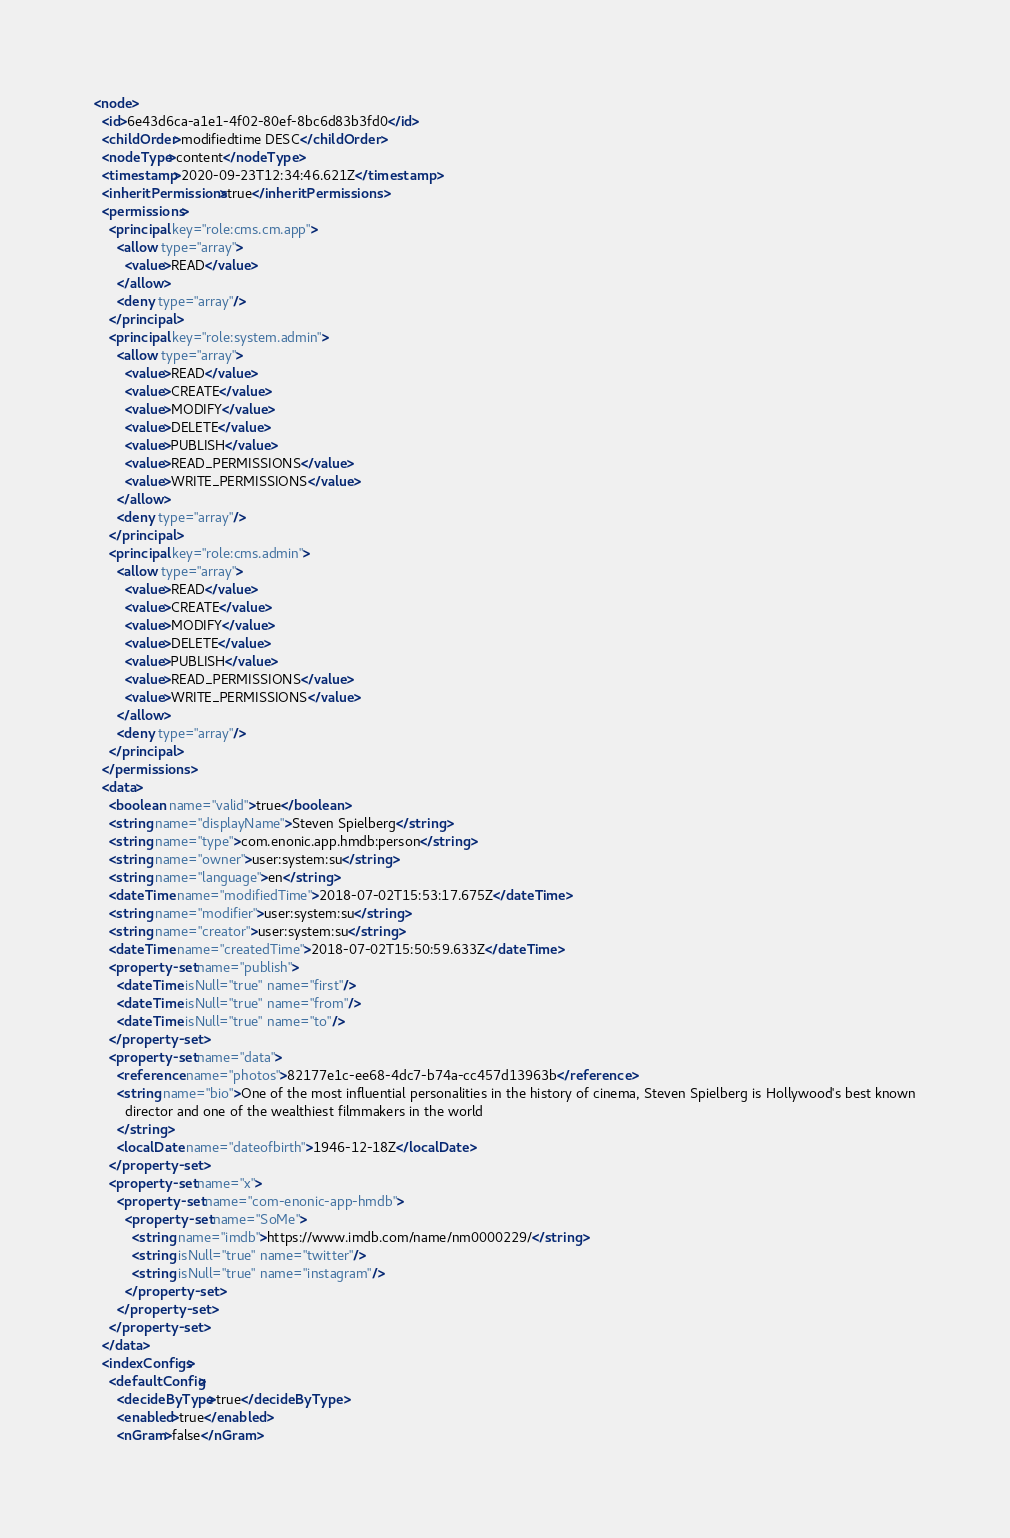Convert code to text. <code><loc_0><loc_0><loc_500><loc_500><_XML_><node>
  <id>6e43d6ca-a1e1-4f02-80ef-8bc6d83b3fd0</id>
  <childOrder>modifiedtime DESC</childOrder>
  <nodeType>content</nodeType>
  <timestamp>2020-09-23T12:34:46.621Z</timestamp>
  <inheritPermissions>true</inheritPermissions>
  <permissions>
    <principal key="role:cms.cm.app">
      <allow type="array">
        <value>READ</value>
      </allow>
      <deny type="array"/>
    </principal>
    <principal key="role:system.admin">
      <allow type="array">
        <value>READ</value>
        <value>CREATE</value>
        <value>MODIFY</value>
        <value>DELETE</value>
        <value>PUBLISH</value>
        <value>READ_PERMISSIONS</value>
        <value>WRITE_PERMISSIONS</value>
      </allow>
      <deny type="array"/>
    </principal>
    <principal key="role:cms.admin">
      <allow type="array">
        <value>READ</value>
        <value>CREATE</value>
        <value>MODIFY</value>
        <value>DELETE</value>
        <value>PUBLISH</value>
        <value>READ_PERMISSIONS</value>
        <value>WRITE_PERMISSIONS</value>
      </allow>
      <deny type="array"/>
    </principal>
  </permissions>
  <data>
    <boolean name="valid">true</boolean>
    <string name="displayName">Steven Spielberg</string>
    <string name="type">com.enonic.app.hmdb:person</string>
    <string name="owner">user:system:su</string>
    <string name="language">en</string>
    <dateTime name="modifiedTime">2018-07-02T15:53:17.675Z</dateTime>
    <string name="modifier">user:system:su</string>
    <string name="creator">user:system:su</string>
    <dateTime name="createdTime">2018-07-02T15:50:59.633Z</dateTime>
    <property-set name="publish">
      <dateTime isNull="true" name="first"/>
      <dateTime isNull="true" name="from"/>
      <dateTime isNull="true" name="to"/>
    </property-set>
    <property-set name="data">
      <reference name="photos">82177e1c-ee68-4dc7-b74a-cc457d13963b</reference>
      <string name="bio">One of the most influential personalities in the history of cinema, Steven Spielberg is Hollywood's best known
        director and one of the wealthiest filmmakers in the world
      </string>
      <localDate name="dateofbirth">1946-12-18Z</localDate>
    </property-set>
    <property-set name="x">
      <property-set name="com-enonic-app-hmdb">
        <property-set name="SoMe">
          <string name="imdb">https://www.imdb.com/name/nm0000229/</string>
          <string isNull="true" name="twitter"/>
          <string isNull="true" name="instagram"/>
        </property-set>
      </property-set>
    </property-set>
  </data>
  <indexConfigs>
    <defaultConfig>
      <decideByType>true</decideByType>
      <enabled>true</enabled>
      <nGram>false</nGram></code> 